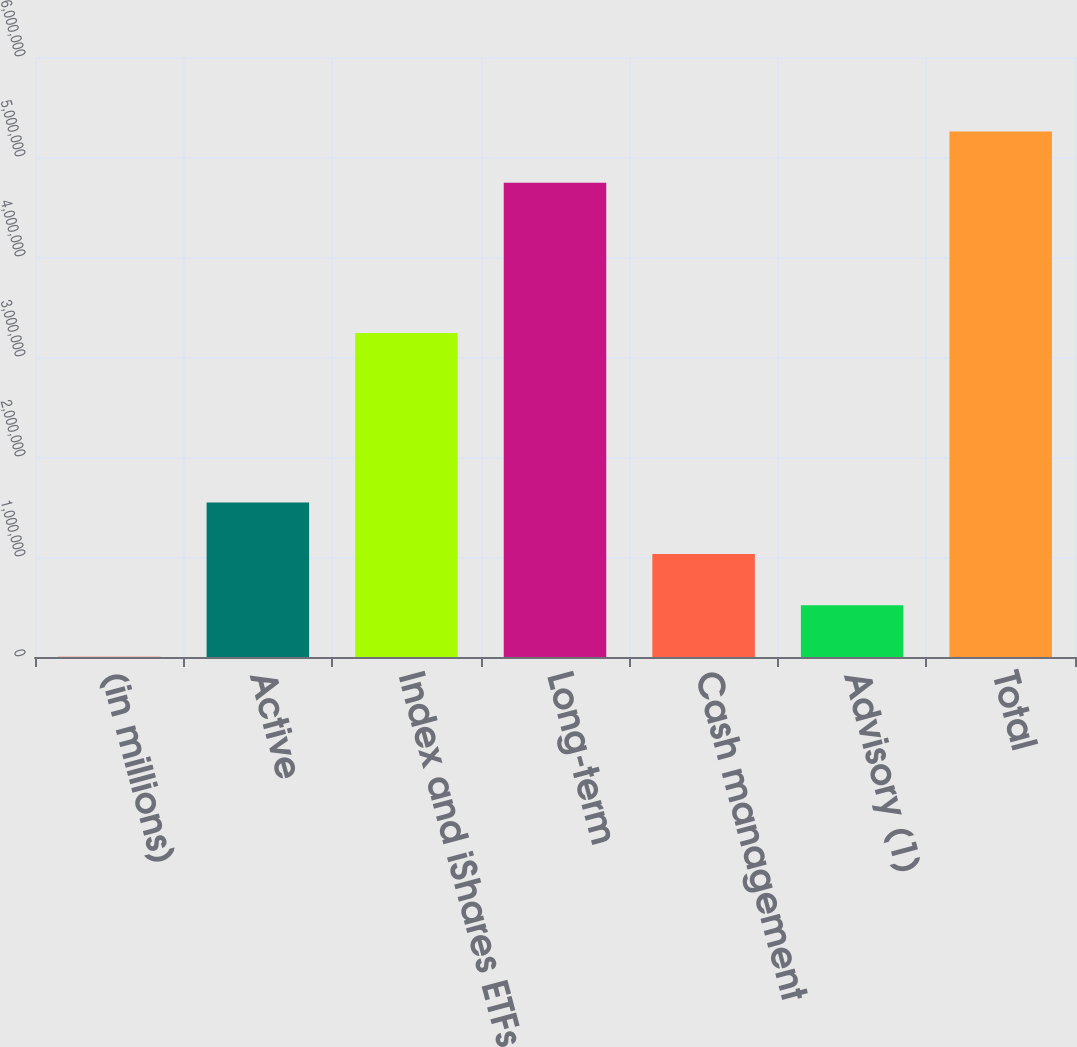Convert chart. <chart><loc_0><loc_0><loc_500><loc_500><bar_chart><fcel>(in millions)<fcel>Active<fcel>Index and iShares ETFs<fcel>Long-term<fcel>Cash management<fcel>Advisory (1)<fcel>Total<nl><fcel>2016<fcel>1.54577e+06<fcel>3.24043e+06<fcel>4.74149e+06<fcel>1.03118e+06<fcel>516600<fcel>5.25607e+06<nl></chart> 